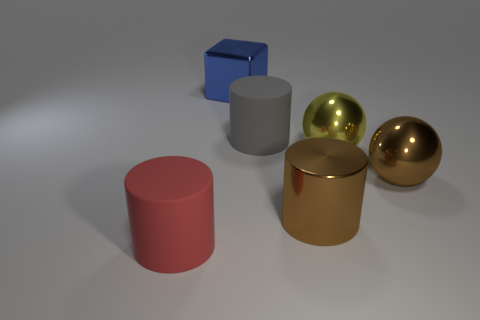Subtract all gray cylinders. How many cylinders are left? 2 Subtract all gray cylinders. How many cylinders are left? 2 Subtract 1 cylinders. How many cylinders are left? 2 Add 1 cyan metal cubes. How many objects exist? 7 Subtract all spheres. How many objects are left? 4 Subtract all yellow cylinders. Subtract all green balls. How many cylinders are left? 3 Subtract all tiny green rubber cylinders. Subtract all large brown objects. How many objects are left? 4 Add 1 red cylinders. How many red cylinders are left? 2 Add 6 small purple rubber cylinders. How many small purple rubber cylinders exist? 6 Subtract 0 cyan blocks. How many objects are left? 6 